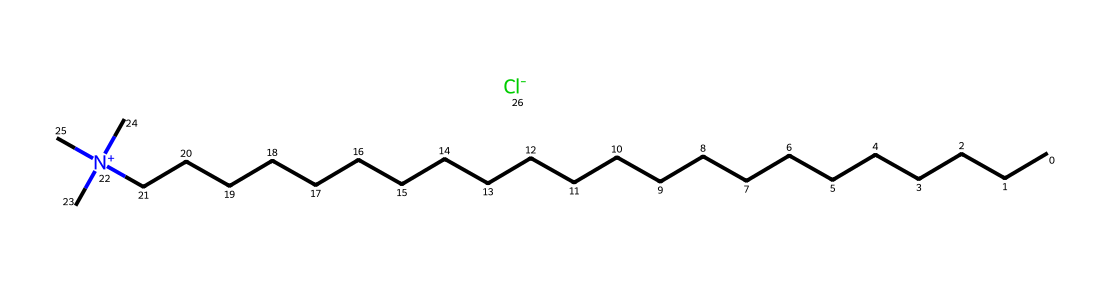What is the molecular formula of behentrimonium chloride? To determine the molecular formula, we analyze the SMILES representation. The long chain indicates a hydrocarbon backbone with 22 carbon atoms (C) and it ends with a quaternary ammonium group that includes one nitrogen (N) and three methyl groups (C). Additionally, there is one chloride ion (Cl). Therefore, the formula is C22H46ClN.
Answer: C22H46ClN How many carbon atoms are present in behentrimonium chloride? The SMILES representation shows a long chain of 'C' letters. Counting them, there are 22 carbon atoms in total in behentrimonium chloride.
Answer: 22 What type of ion is represented by '[Cl-]' in this chemical? The '[Cl-]' notation indicates a chloride ion, which is a negatively charged ion. It balances the positive charge of the quaternary ammonium group in behentrimonium chloride.
Answer: chloride ion Why does behentrimonium chloride function as a surfactant? Behentrimonium chloride is a surfactant due to its quaternary ammonium structure, which has a hydrophilic (water-attracting) head (the nitrogen with attached groups) and a long hydrophobic (water-repelling) tail (the carbon chain). This dual nature allows it to reduce surface tension and emulsify substances, making it effective in hair conditioners.
Answer: hydrophilic and hydrophobic What is the main functional group in behentrimonium chloride? The main functional group in the chemical is the quaternary ammonium group, which is characterized by a nitrogen atom bonded to four groups. This is crucial for its activity as a surfactant and conditioning agent.
Answer: quaternary ammonium group 